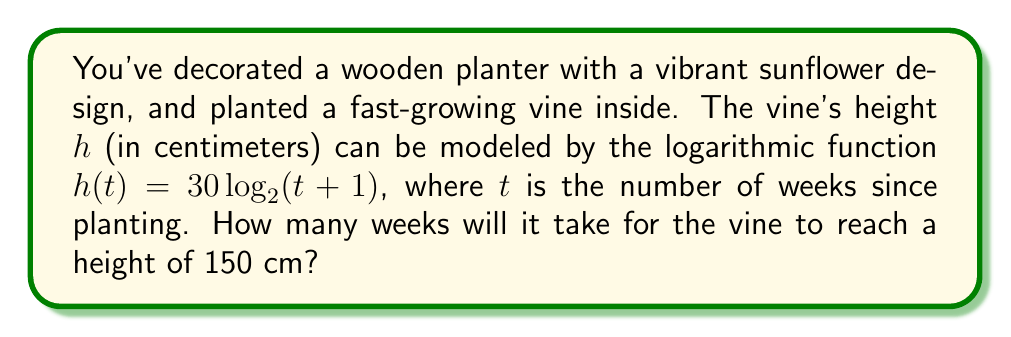Could you help me with this problem? Let's solve this step-by-step:

1) We're given the logarithmic function: $h(t) = 30 \log_2(t + 1)$

2) We want to find $t$ when $h(t) = 150$ cm. So, let's set up the equation:

   $150 = 30 \log_2(t + 1)$

3) First, divide both sides by 30:

   $5 = \log_2(t + 1)$

4) Now, we need to solve for $t$. We can do this by applying the inverse function (exponential) to both sides:

   $2^5 = t + 1$

5) Simplify the left side:

   $32 = t + 1$

6) Subtract 1 from both sides:

   $31 = t$

Therefore, it will take 31 weeks for the vine to reach a height of 150 cm.
Answer: 31 weeks 